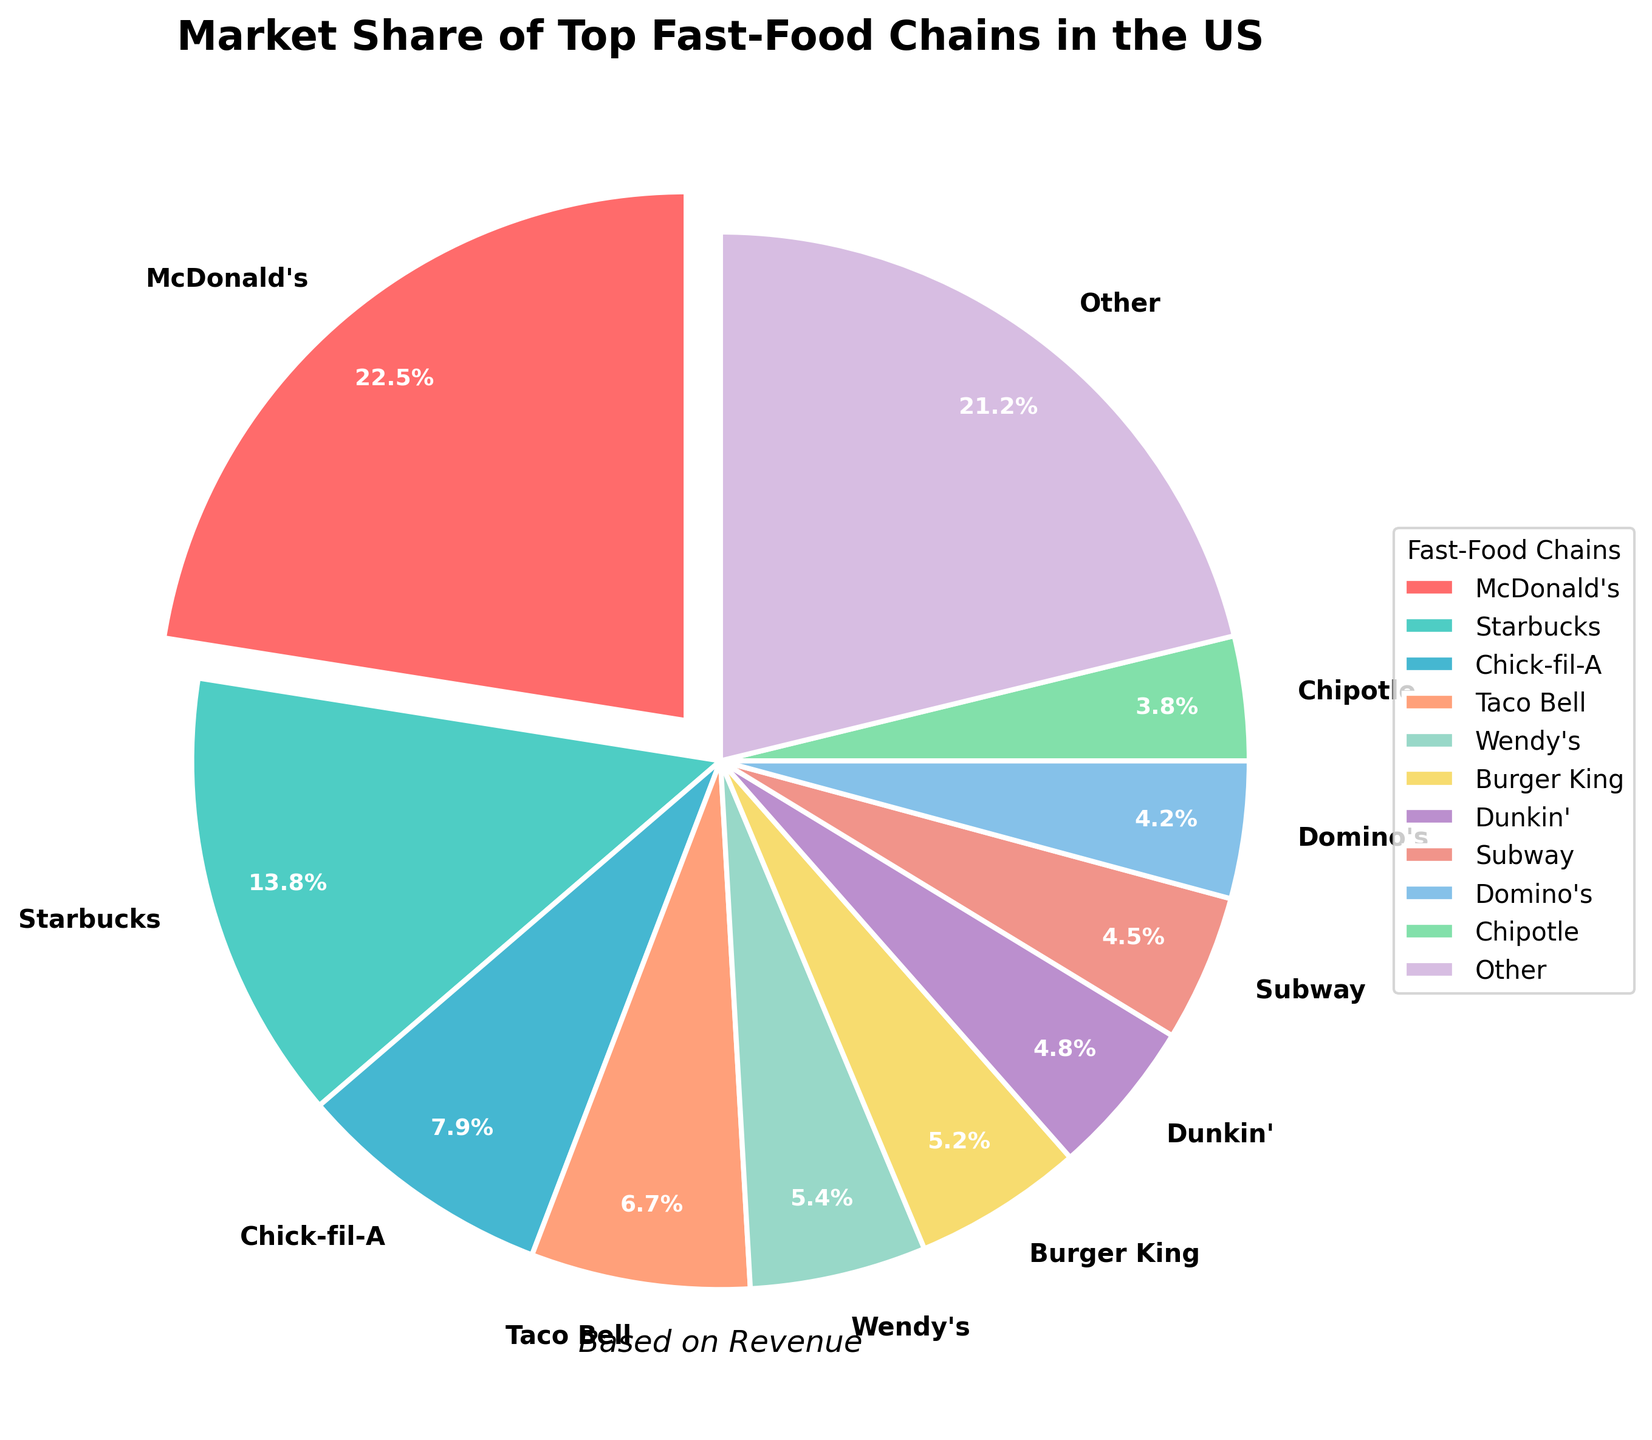Which fast-food chain has the largest market share? McDonald's, with the market share indicated by the largest slice and the label showing 22.5%.
Answer: McDonald's What is the combined market share of Chick-fil-A, Taco Bell, and Wendy's? Add the market shares of Chick-fil-A (7.9%), Taco Bell (6.7%), and Wendy's (5.4%). Calculation: 7.9 + 6.7 + 5.4 = 20.0%.
Answer: 20.0% Which chain has a larger market share, Subway or Dunkin'? Compare the slices and labels for Subway (4.5%) and Dunkin' (4.8%). Dunkin’s slice is slightly larger.
Answer: Dunkin' How much more market share does McDonald's have compared to Burger King? Subtract Burger King's market share (5.2%) from McDonald's market share (22.5%). Calculation: 22.5 - 5.2 = 17.3%.
Answer: 17.3% Is the market share of “Other” greater than the combined market share of Domino's and Chipotle? Compare the market share of "Other" (21.2%) to the sum of Domino's (4.2%) and Chipotle (3.8%). Calculation: 4.2 + 3.8 = 8.0%. 21.2% is greater than 8.0%.
Answer: Yes What percentage of the market share is controlled by the smallest top 5 chain compared to the largest? Compare the smallest top 5 chain (Wendy's, 5.4%) to the largest (McDonald's, 22.5%). Calculation: (5.4 / 22.5) * 100 ≈ 24%.
Answer: ≈ 24% Which chain has approximately double the market share of Chipotle? Check the slices and labels, find a chain with a market share approximately double that of Chipotle (3.8%). Domino's has 4.2%, Dunkin' has 4.8%, but Taco Bell has about double at 6.7% (since 2 * 3.8 ≈ 7.6).
Answer: Taco Bell Which chains form the top half of the market by combining their shares? Add the top shares until half the total market (50%) is reached. McDonald's (22.5%) + Starbucks (13.8%) + Chick-fil-A (7.9%) + Taco Bell (6.7%) = 50.9%. The top four chains together form just over half the market.
Answer: McDonald's, Starbucks, Chick-fil-A, Taco Bell If "Other" was divided into 5 equal parts, how much market share would each part represent? Divide the "Other" category market share (21.2%) by 5. Calculation: 21.2 / 5 = 4.24%.
Answer: 4.24% 